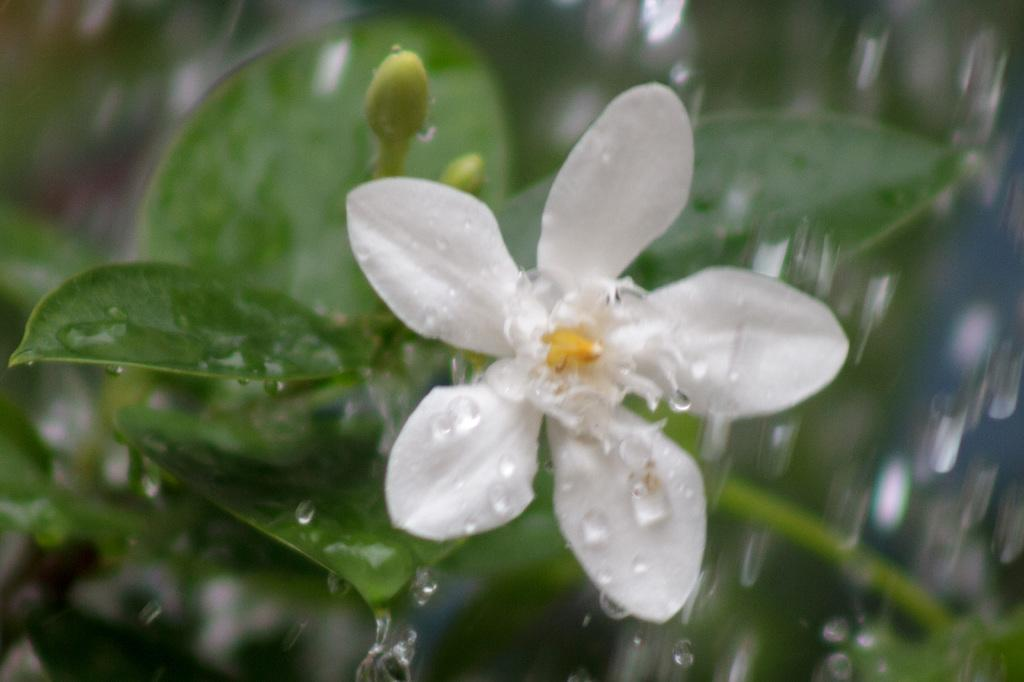What type of plant is featured in the image? There is a white flower in the image. What other parts of the plant can be seen besides the flower? The flower has leaves. What is the condition of the flower or its leaves in the image? There are water droplets on the flower or its leaves. What type of camera is visible in the image? There is no camera present in the image; it features a white flower with leaves and water droplets. What kind of structure can be seen supporting the flower in the image? There is no structure supporting the flower in the image; it is a standalone plant. 